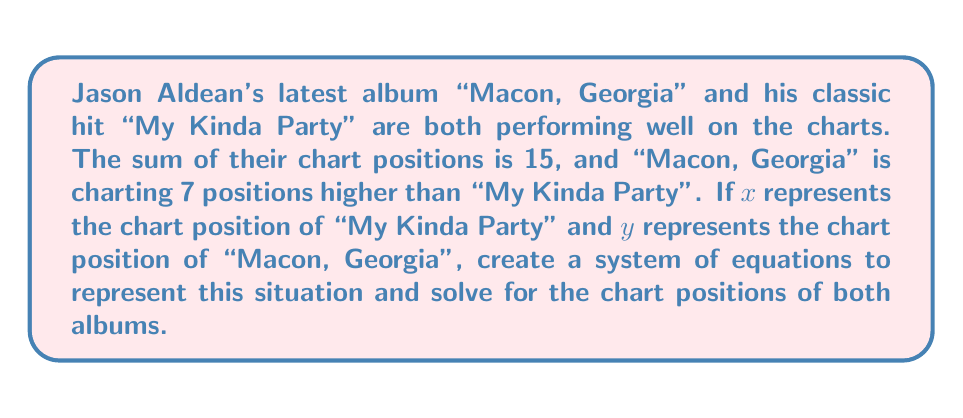Provide a solution to this math problem. Let's approach this step-by-step:

1) First, let's define our variables:
   $x$ = chart position of "My Kinda Party"
   $y$ = chart position of "Macon, Georgia"

2) Now, let's create our system of equations based on the given information:

   Equation 1: The sum of their chart positions is 15
   $$x + y = 15$$

   Equation 2: "Macon, Georgia" is charting 7 positions higher than "My Kinda Party"
   $$y = x - 7$$

3) We now have a system of two equations with two unknowns:
   $$\begin{cases}
   x + y = 15 \\
   y = x - 7
   \end{cases}$$

4) We can solve this using substitution. Let's substitute the second equation into the first:
   $$x + (x - 7) = 15$$

5) Simplify:
   $$2x - 7 = 15$$

6) Add 7 to both sides:
   $$2x = 22$$

7) Divide both sides by 2:
   $$x = 11$$

8) Now that we know $x$, we can find $y$ using either of our original equations. Let's use the second one:
   $$y = x - 7 = 11 - 7 = 4$$

Therefore, "My Kinda Party" is at position 11, and "Macon, Georgia" is at position 4.
Answer: "My Kinda Party" is at chart position 11, and "Macon, Georgia" is at chart position 4. 